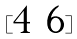Convert formula to latex. <formula><loc_0><loc_0><loc_500><loc_500>[ \begin{matrix} 4 & 6 \end{matrix} ]</formula> 